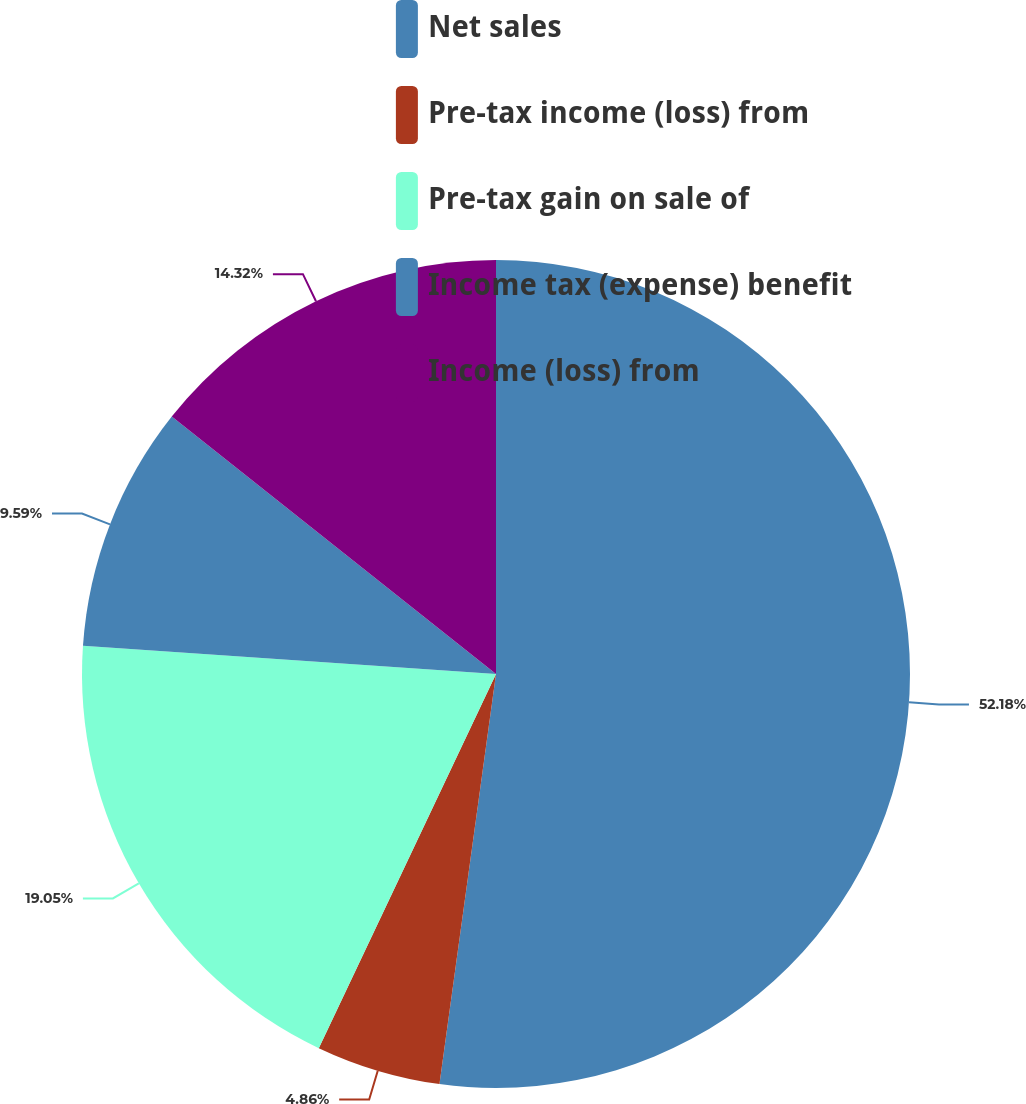Convert chart to OTSL. <chart><loc_0><loc_0><loc_500><loc_500><pie_chart><fcel>Net sales<fcel>Pre-tax income (loss) from<fcel>Pre-tax gain on sale of<fcel>Income tax (expense) benefit<fcel>Income (loss) from<nl><fcel>52.18%<fcel>4.86%<fcel>19.05%<fcel>9.59%<fcel>14.32%<nl></chart> 